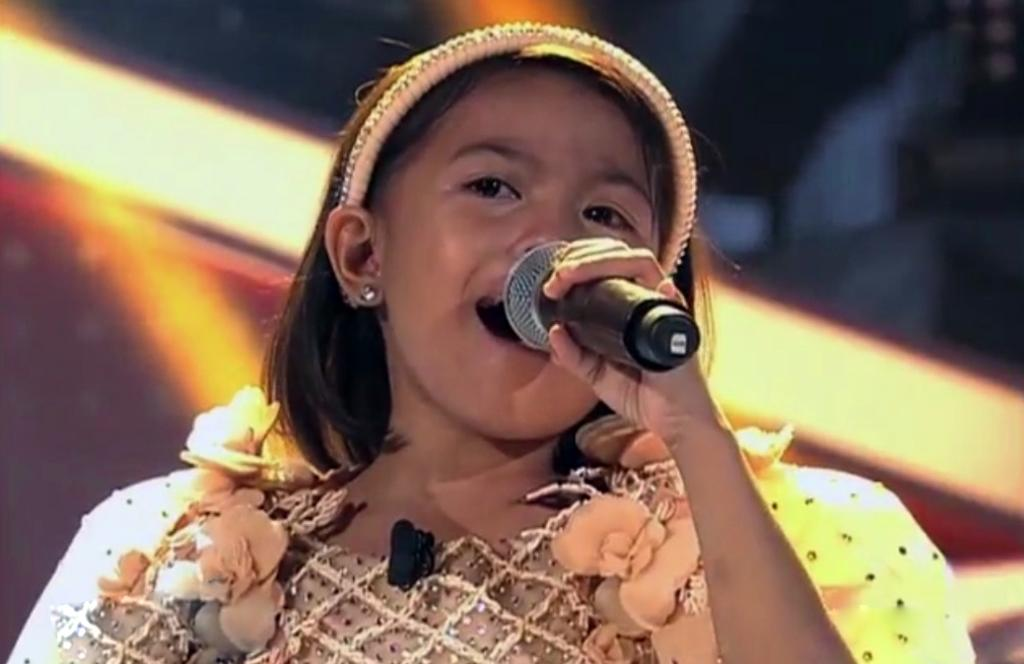Who is the main subject in the image? There is a girl in the image. What is the girl holding in her hand? The girl is holding a mic in her hand. Can you describe the background of the image? The background of the image is blurry. What type of stem can be seen growing from the girl's head in the image? There is no stem growing from the girl's head in the image. 